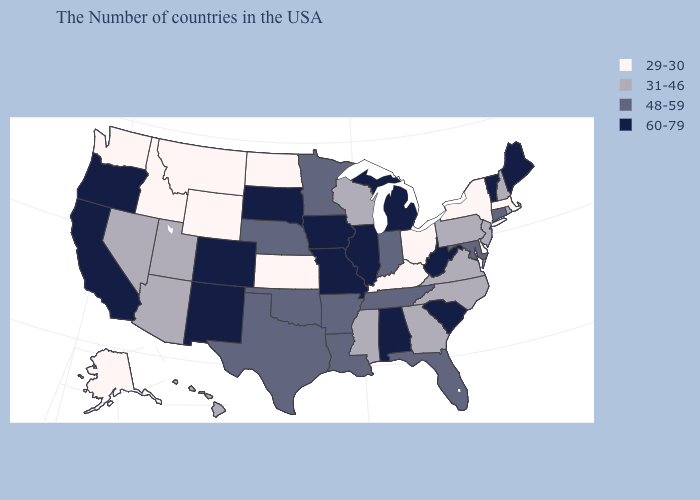Does the map have missing data?
Keep it brief. No. Which states have the highest value in the USA?
Concise answer only. Maine, Vermont, South Carolina, West Virginia, Michigan, Alabama, Illinois, Missouri, Iowa, South Dakota, Colorado, New Mexico, California, Oregon. Which states have the lowest value in the MidWest?
Short answer required. Ohio, Kansas, North Dakota. Which states have the lowest value in the Northeast?
Write a very short answer. Massachusetts, New York. What is the value of Maine?
Short answer required. 60-79. Name the states that have a value in the range 29-30?
Concise answer only. Massachusetts, New York, Delaware, Ohio, Kentucky, Kansas, North Dakota, Wyoming, Montana, Idaho, Washington, Alaska. What is the lowest value in states that border Rhode Island?
Give a very brief answer. 29-30. Does New Hampshire have the lowest value in the Northeast?
Keep it brief. No. Is the legend a continuous bar?
Be succinct. No. What is the value of Kentucky?
Short answer required. 29-30. What is the value of Alaska?
Keep it brief. 29-30. Name the states that have a value in the range 31-46?
Be succinct. Rhode Island, New Hampshire, New Jersey, Pennsylvania, Virginia, North Carolina, Georgia, Wisconsin, Mississippi, Utah, Arizona, Nevada, Hawaii. What is the value of Wyoming?
Short answer required. 29-30. What is the value of Alabama?
Answer briefly. 60-79. What is the value of Rhode Island?
Short answer required. 31-46. 